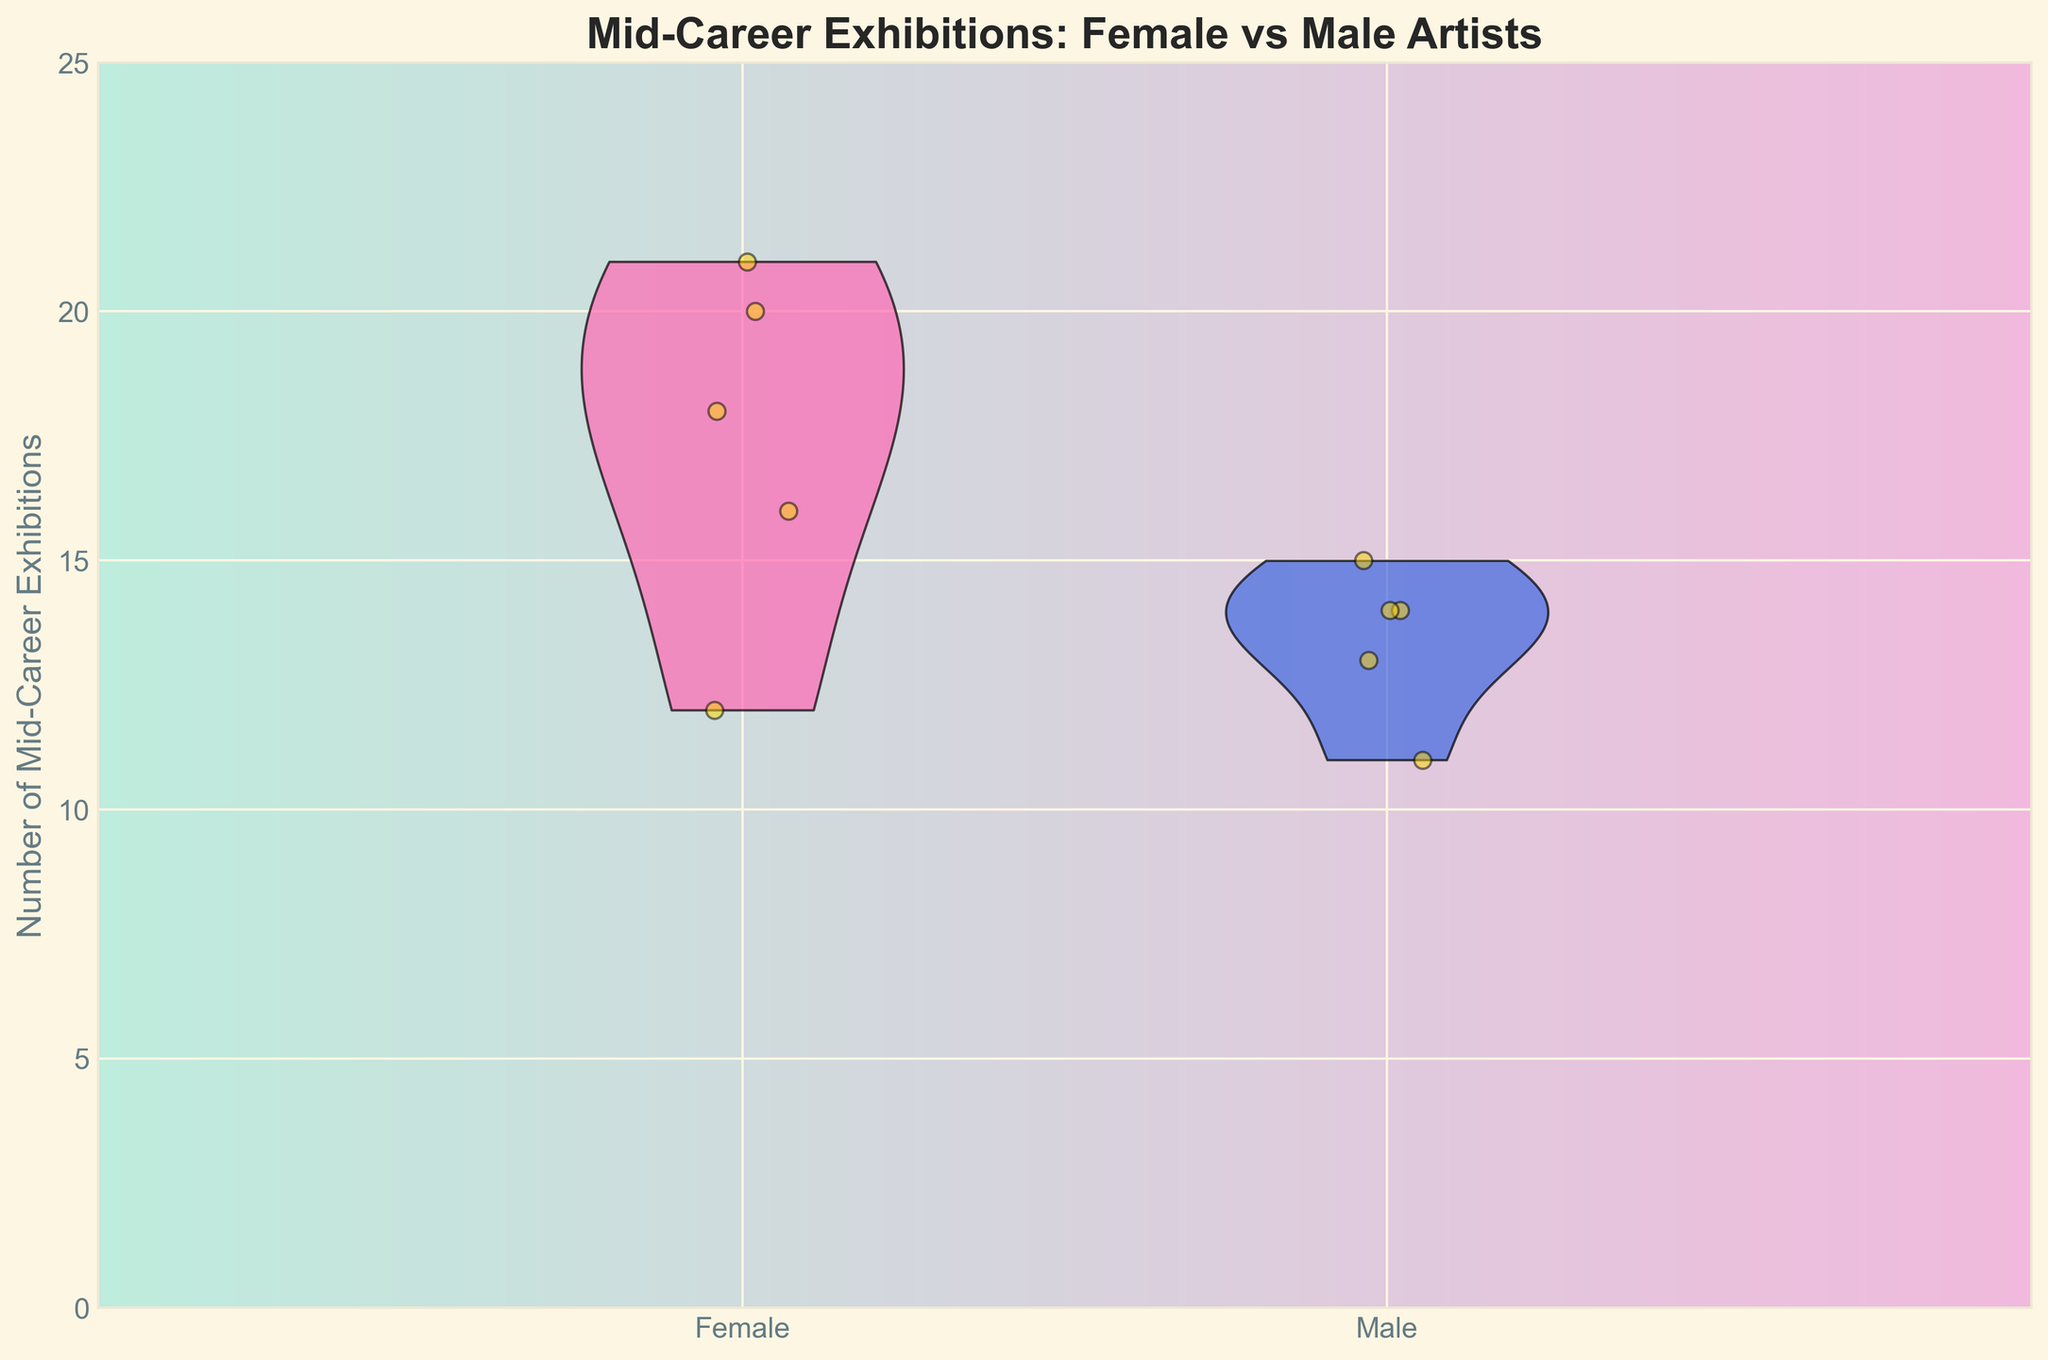What is the title of the figure? The title is usually written at the top of the figure to provide a summary of what the figure is about. The title of the figure indicates the main topic or the main comparison being visualized.
Answer: Mid-Career Exhibitions: Female vs Male Artists What are the x-axis categories? The x-axis of the figure labels the two categories being compared. The x-axis labels help in understanding which group each violin plot represents.
Answer: Female and Male What color represents female artists in the split violin plot? The colors in the figure differentiate between the two groups. Each violin plot is colored differently to represent either Female or Male artists. By observing the plot, it's clear which color corresponds to which gender.
Answer: Pink How many major data points are displayed for female mid-career exhibitions? The number of data points for a category can be counted from the scatter points overlaid on the violin plot. Each point represents an individual data point.
Answer: Five What's the median number of mid-career exhibitions for male artists? To find the median, count the total numbers in each distribution, order them, and find the middle value. Here we visually inspect the spread and center of the male artists' violin plot to determine the approximate median.
Answer: Approximately 14 How do mid-career exhibition data for females and males compare? By observing the spread and density of the two violin plots, we can compare the general trends and central values of mid-career exhibitions between female and male artists. The plot shape indicates the distribution.
Answer: Female artists show a higher and wider spread What's the interquartile range (IQR) of mid-career exhibitions for female artists? The interquartile range (IQR) is the range within which the middle 50% of the data falls. Observing the density and spread within the female violin plot enables determining the approximate IQR.
Answer: Approximately 11 (from 10 to 21) Which gender has a higher maximum number of mid-career exhibitions? The height of the violin plots indicates the range of data. By determining the peak of each plot, we can see which gender reaches a higher value.
Answer: Female Are there any female artists with over 20 exhibitions? By examining the scatter points overlaid on the female violin plot, we can see whether any points lie beyond the 20 exhibitions mark.
Answer: Yes What is the range of mid-career exhibitions for male artists? The range is determined by the minimum and maximum values within the violin plot for male artists. Observing the ends of the plot gives this information.
Answer: From 11 to 15 